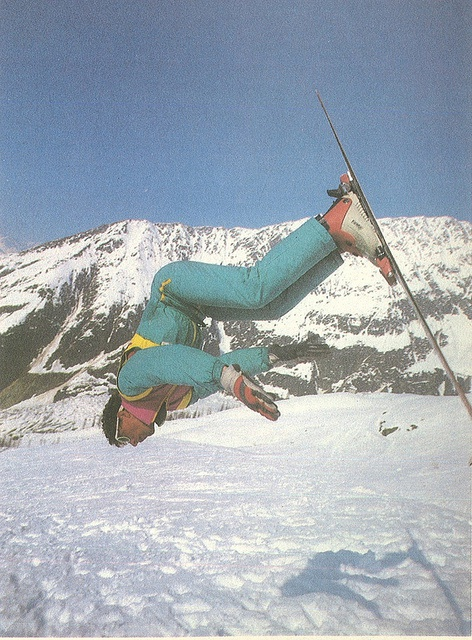Describe the objects in this image and their specific colors. I can see people in gray, teal, ivory, and darkgray tones and skis in gray, darkgray, and ivory tones in this image. 